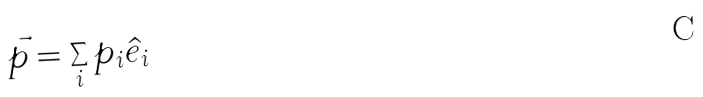Convert formula to latex. <formula><loc_0><loc_0><loc_500><loc_500>\vec { p } = \sum _ { i } p _ { i } \hat { e } _ { i }</formula> 